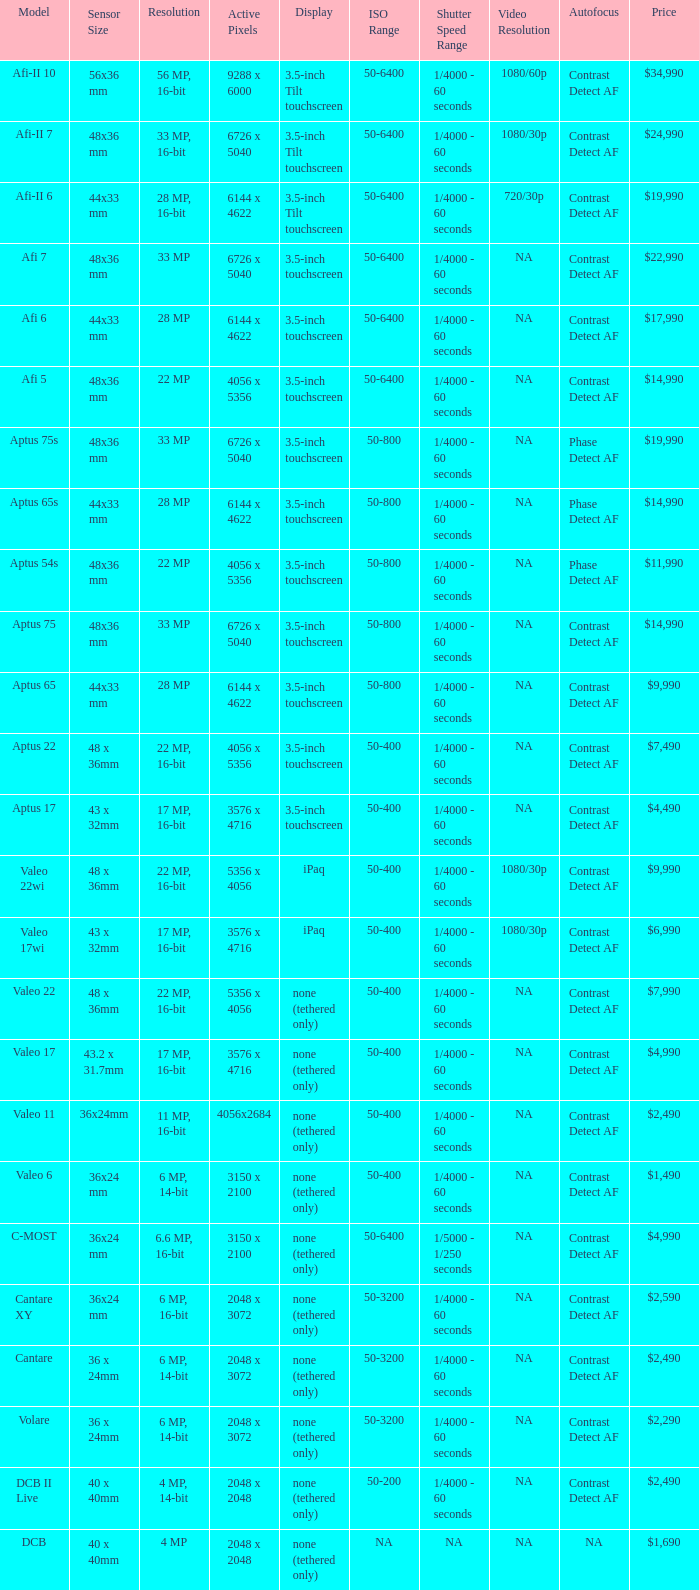Which model has a sensor sized 48x36 mm, pixels of 6726 x 5040, and a 33 mp resolution? Afi 7, Aptus 75s, Aptus 75. 